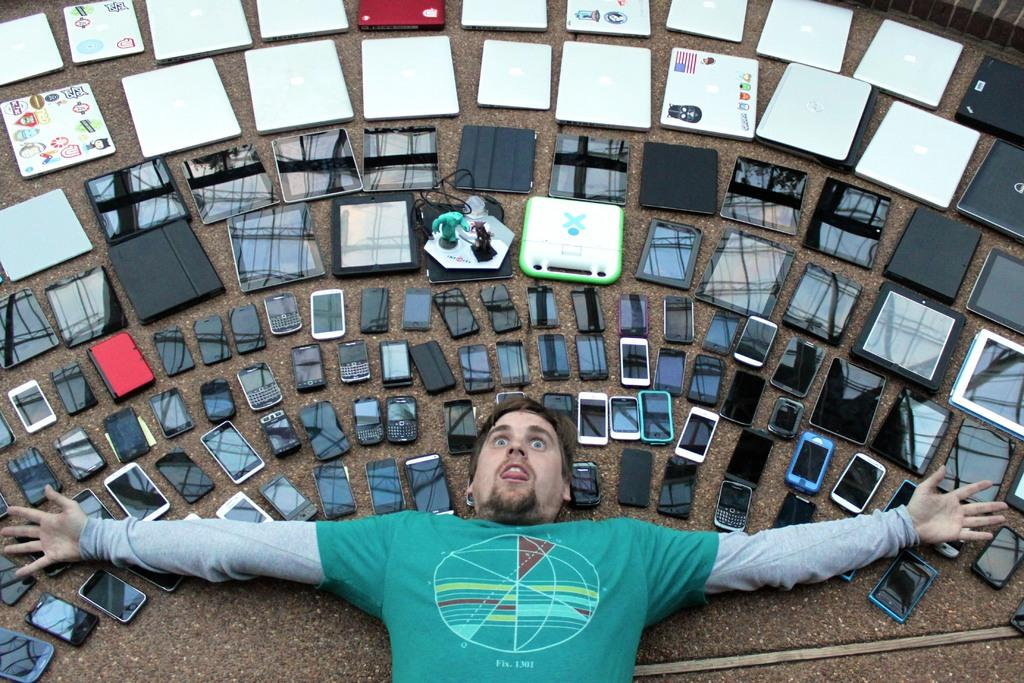What is the position of the man in the image? The man is laying on the floor in the image. What types of electronic devices are on the floor? There are different kinds of mobiles, tablets, and laptops on the floor. How many ants can be seen crawling on the laptops in the image? There are no ants visible in the image; it only shows a man laying on the floor and electronic devices on the floor. 